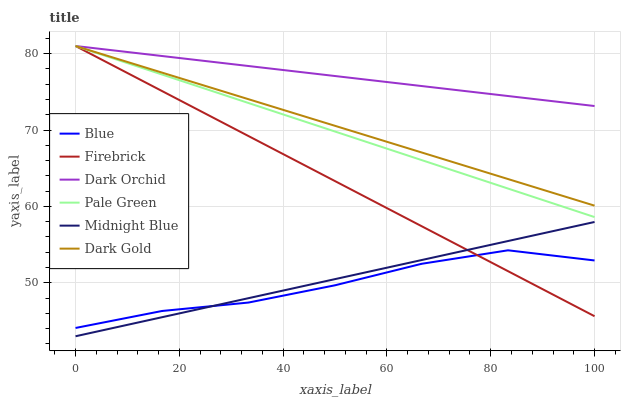Does Blue have the minimum area under the curve?
Answer yes or no. Yes. Does Dark Orchid have the maximum area under the curve?
Answer yes or no. Yes. Does Midnight Blue have the minimum area under the curve?
Answer yes or no. No. Does Midnight Blue have the maximum area under the curve?
Answer yes or no. No. Is Dark Gold the smoothest?
Answer yes or no. Yes. Is Blue the roughest?
Answer yes or no. Yes. Is Midnight Blue the smoothest?
Answer yes or no. No. Is Midnight Blue the roughest?
Answer yes or no. No. Does Midnight Blue have the lowest value?
Answer yes or no. Yes. Does Dark Gold have the lowest value?
Answer yes or no. No. Does Pale Green have the highest value?
Answer yes or no. Yes. Does Midnight Blue have the highest value?
Answer yes or no. No. Is Blue less than Dark Orchid?
Answer yes or no. Yes. Is Dark Orchid greater than Blue?
Answer yes or no. Yes. Does Pale Green intersect Dark Gold?
Answer yes or no. Yes. Is Pale Green less than Dark Gold?
Answer yes or no. No. Is Pale Green greater than Dark Gold?
Answer yes or no. No. Does Blue intersect Dark Orchid?
Answer yes or no. No. 